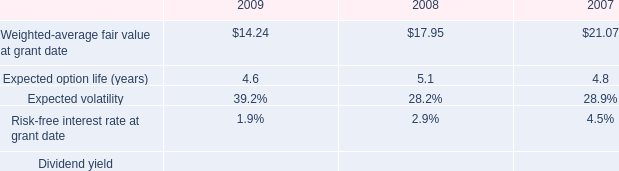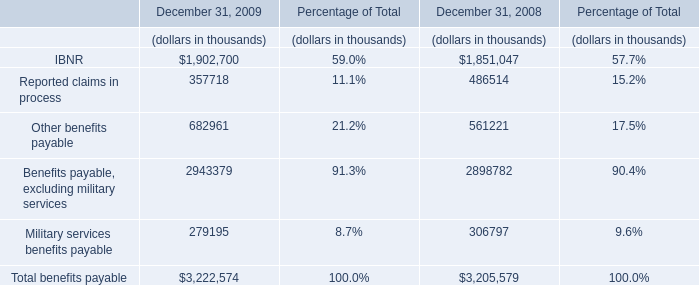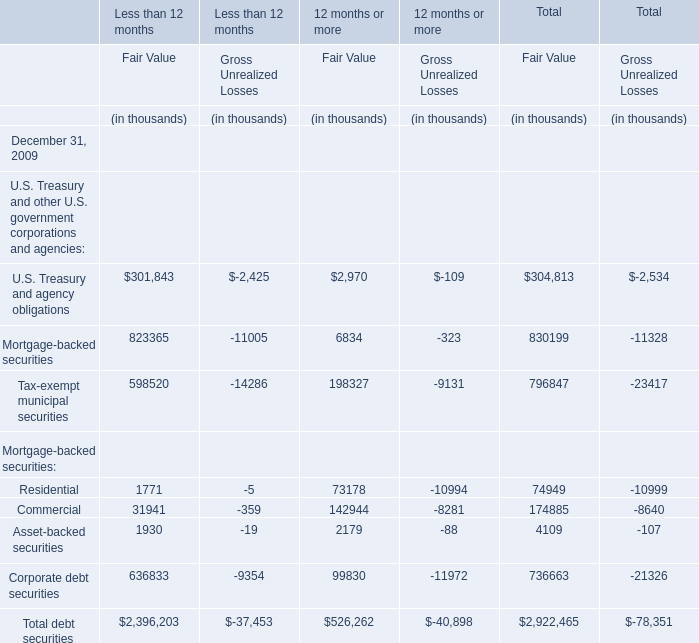What is the sum of elements for Fair Value of 12 months or more in the range of 10000 and 150000 in 2009? (in thousand) 
Computations: ((73178 + 142944) + 99830)
Answer: 315952.0. 